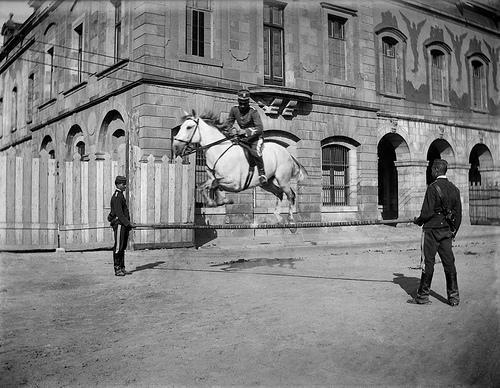How many people are in this picture?
Give a very brief answer. 1. 